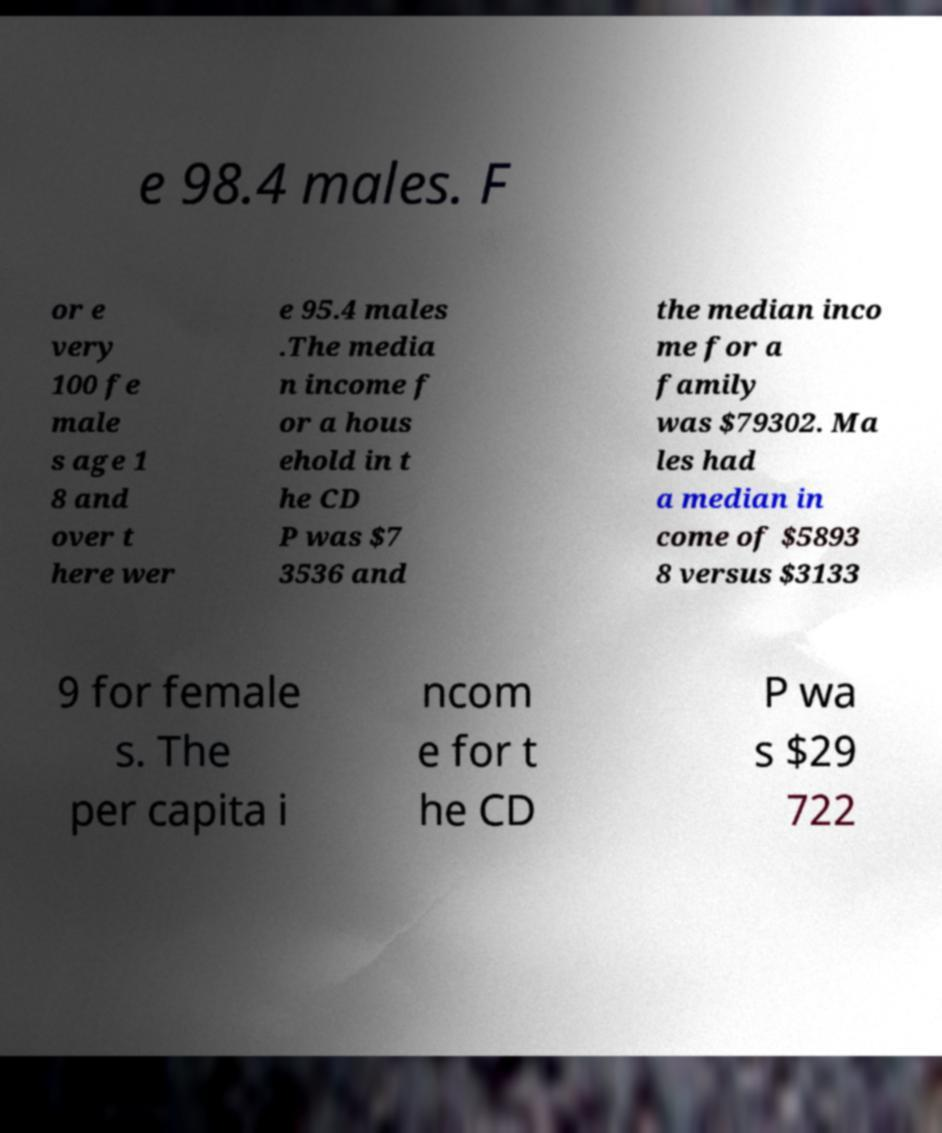Could you extract and type out the text from this image? e 98.4 males. F or e very 100 fe male s age 1 8 and over t here wer e 95.4 males .The media n income f or a hous ehold in t he CD P was $7 3536 and the median inco me for a family was $79302. Ma les had a median in come of $5893 8 versus $3133 9 for female s. The per capita i ncom e for t he CD P wa s $29 722 